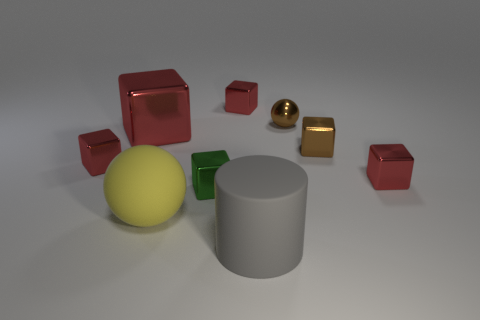Add 1 large rubber spheres. How many objects exist? 10 Subtract all brown metallic cubes. How many cubes are left? 5 Subtract all blocks. How many objects are left? 3 Subtract 1 balls. How many balls are left? 1 Subtract all brown blocks. How many blocks are left? 5 Subtract 3 red blocks. How many objects are left? 6 Subtract all cyan blocks. Subtract all cyan cylinders. How many blocks are left? 6 Subtract all purple blocks. How many yellow balls are left? 1 Subtract all large cylinders. Subtract all tiny brown blocks. How many objects are left? 7 Add 5 brown cubes. How many brown cubes are left? 6 